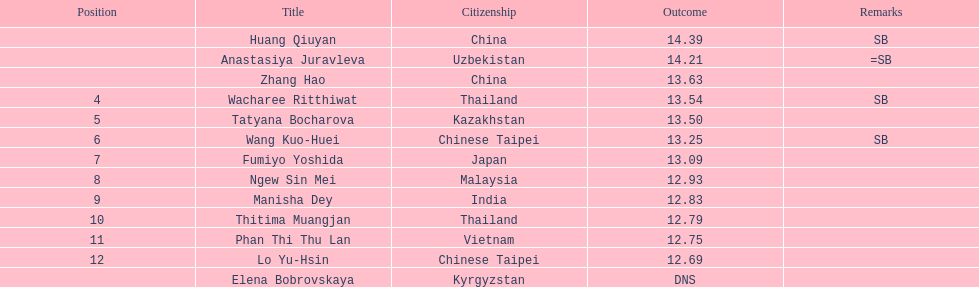What was the average result of the top three jumpers? 14.08. 